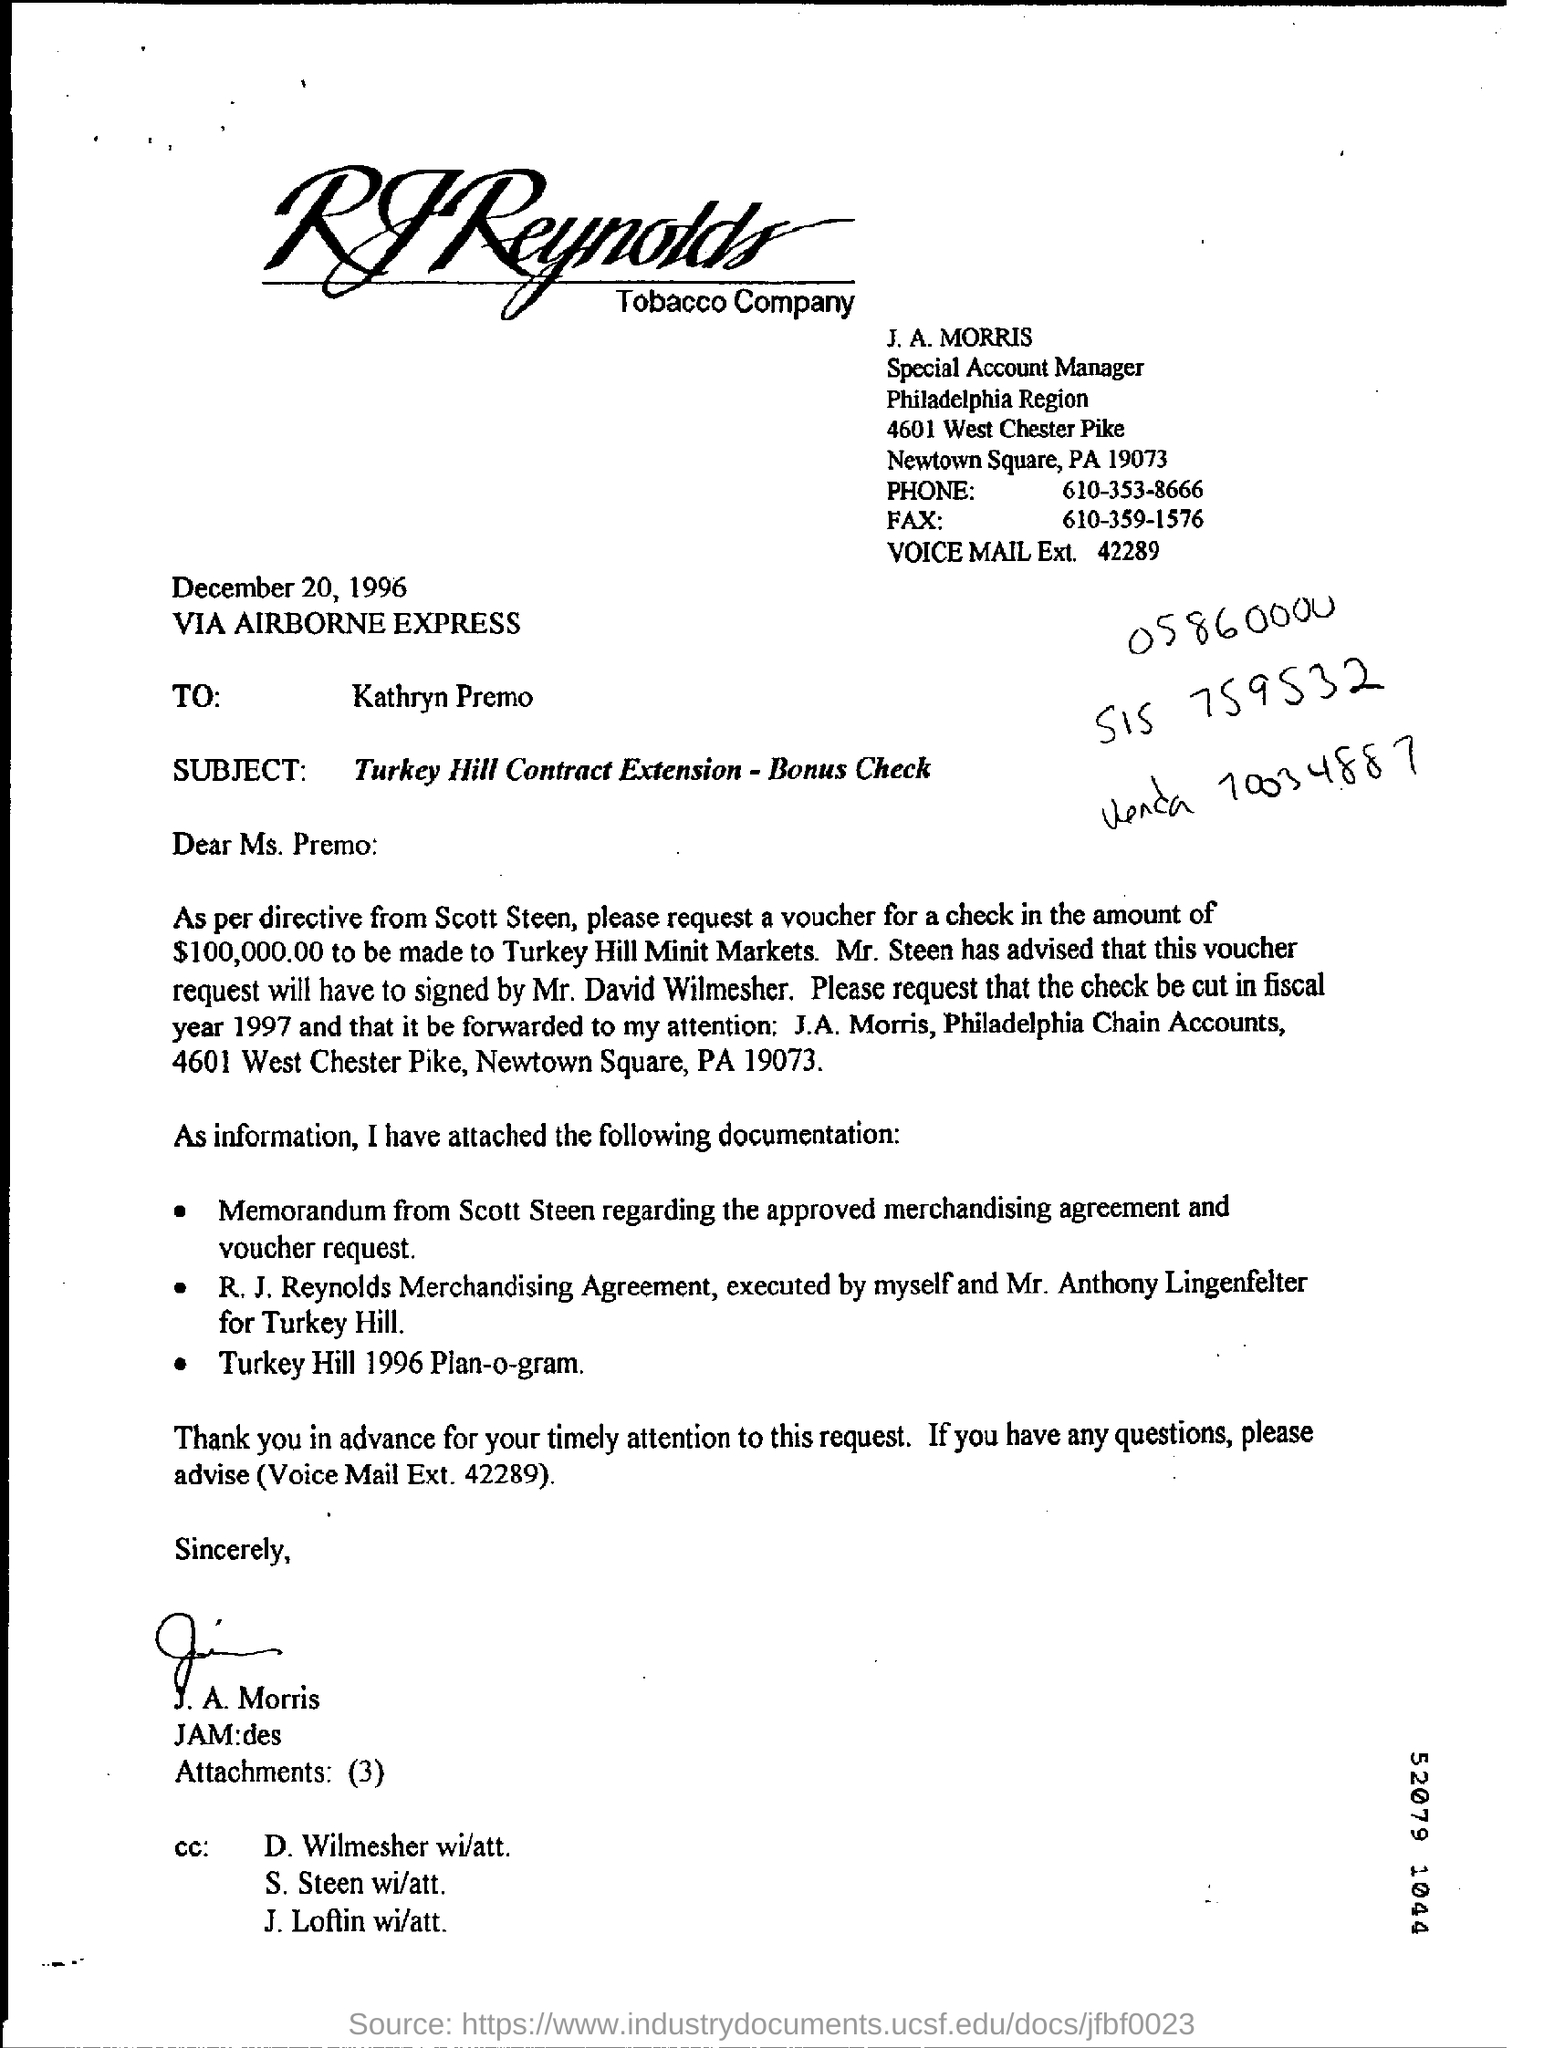Mention a couple of crucial points in this snapshot. According to the document, the check amount mentioned is 100,000.00... 